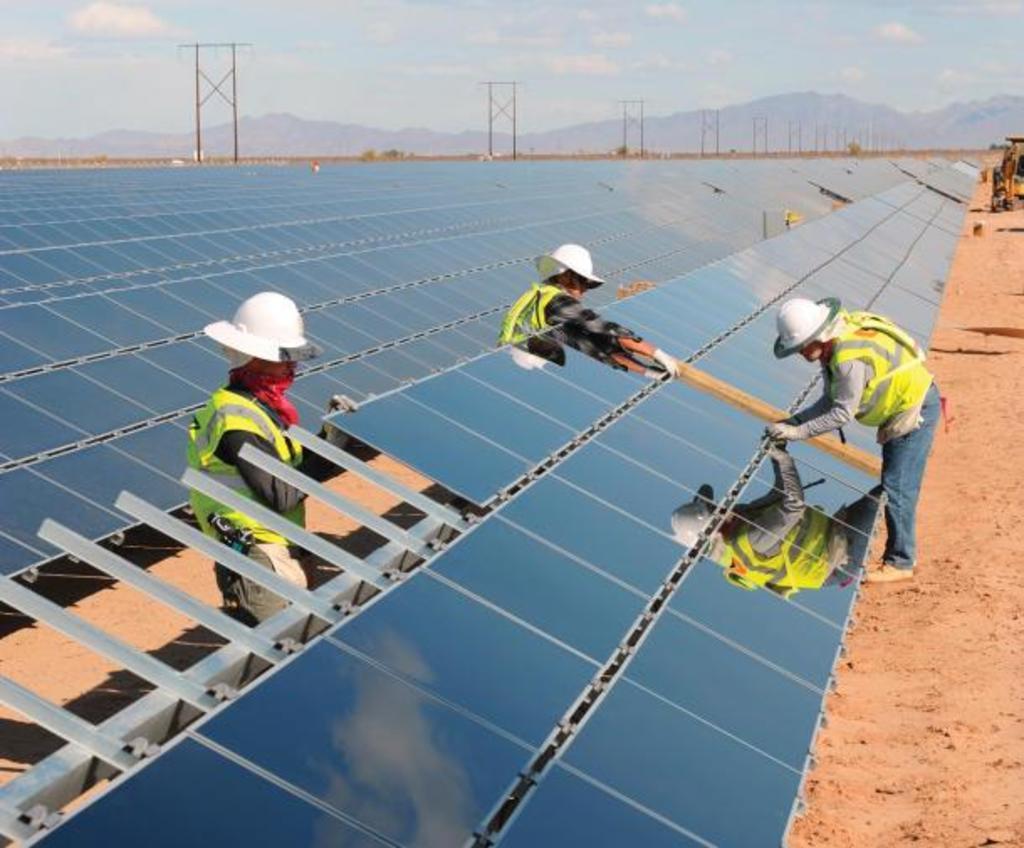Describe this image in one or two sentences. In this image we can see three persons wearing uniforms and helmets are standing on the ground. One person is holding a stick in his hand and one person is holding a glass panel in his hand. In the background we can see a group of panels placed on the ground, poles, mountains and cloudy sky. 